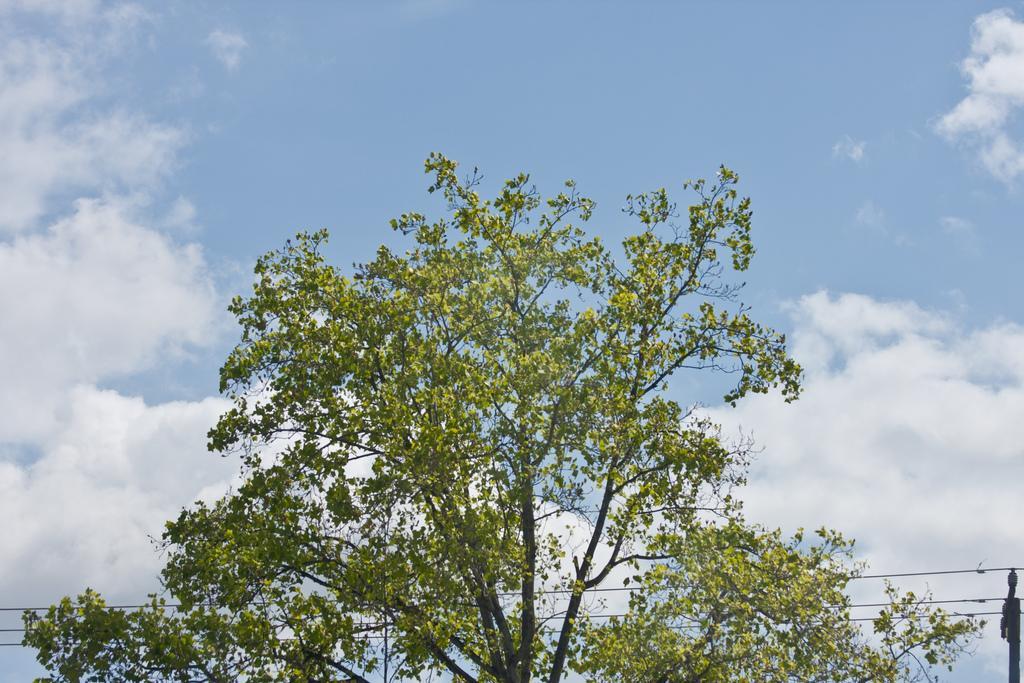Can you describe this image briefly? In this image I can see a tree which is green and black in color, few wires and a pole. In the background I can see the sky. 